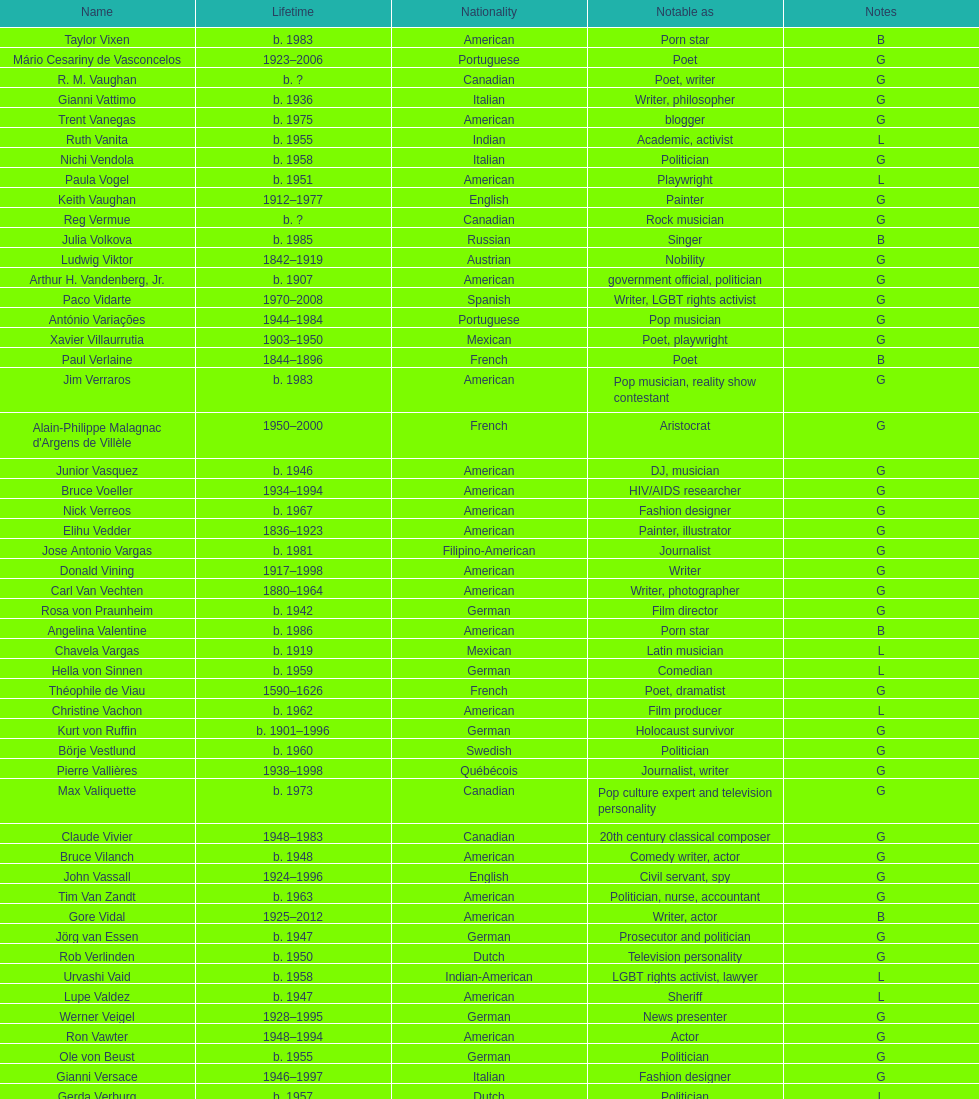Which nationality had the larger amount of names listed? American. 